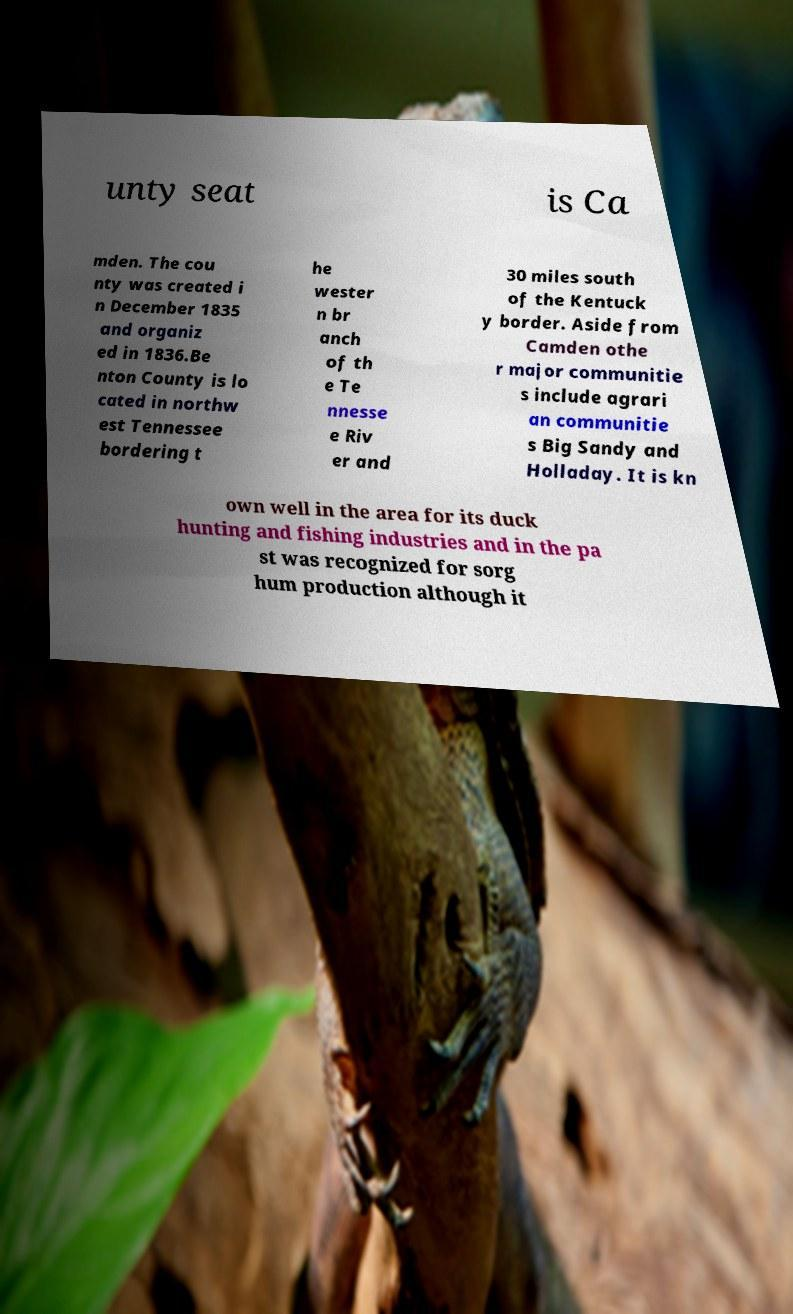I need the written content from this picture converted into text. Can you do that? unty seat is Ca mden. The cou nty was created i n December 1835 and organiz ed in 1836.Be nton County is lo cated in northw est Tennessee bordering t he wester n br anch of th e Te nnesse e Riv er and 30 miles south of the Kentuck y border. Aside from Camden othe r major communitie s include agrari an communitie s Big Sandy and Holladay. It is kn own well in the area for its duck hunting and fishing industries and in the pa st was recognized for sorg hum production although it 